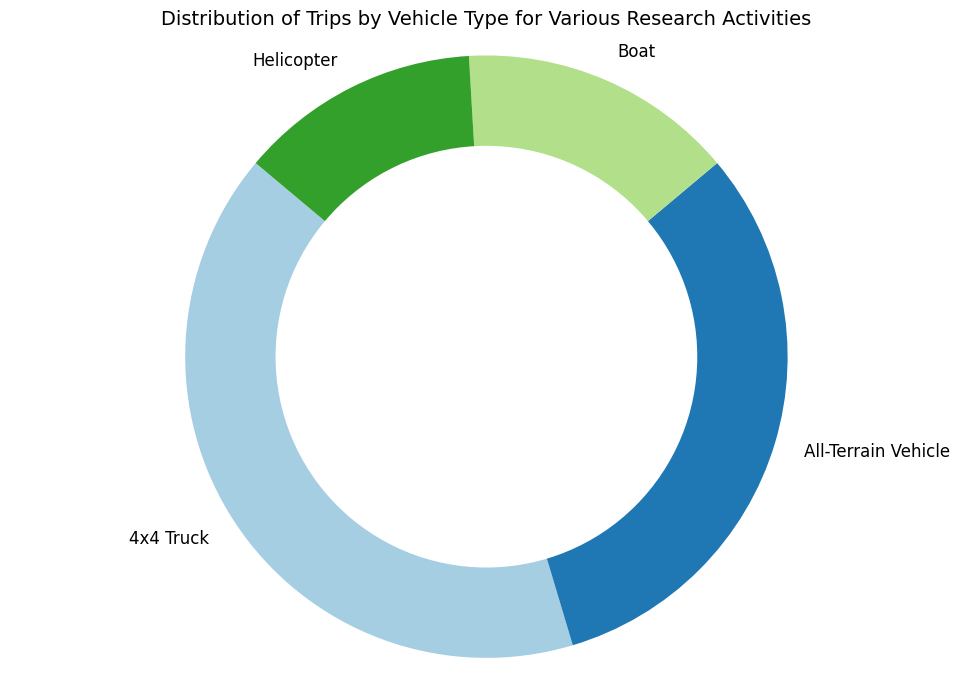What is the total percentage of trips made by All-Terrain Vehicles and 4x4 Trucks combined? Combine the percentages of trips made by All-Terrain Vehicles and 4x4 Trucks. From the chart, All-Terrain Vehicles account for 29.6% and 4x4 Trucks account for 39.4%. Adding these together: 29.6 + 39.4 = 69.0%
Answer: 69.0% Which vehicle type made the fewest trips overall? Identify the smallest percentage segment in the pie chart. The Helicopter segment appears to be the smallest.
Answer: Helicopter Is the percentage of trips made by Boats greater than or less than the percentage of trips made by All-Terrain Vehicles? Compare the size of the segments representing Boats and All-Terrain Vehicles. Boats account for a smaller portion than All-Terrain Vehicles.
Answer: Less than Which vehicle type made the greatest number of trips for habitat monitoring? Identify the vehicle type with the largest segment for the habitat monitoring category in the chart. 4x4 Truck's segment for habitat monitoring is the largest.
Answer: 4x4 Truck How many more trips did All-Terrain Vehicles make for wildlife tracking compared to Helicopters? Calculate the difference between the number of trips made by All-Terrain Vehicles and Helicopters specifically for wildlife tracking. All-Terrain Vehicles made 40 trips, and Helicopters made 10 trips. The difference is 40 - 10 = 30.
Answer: 30 What is the total number of trips made by Helicopters for all research activities? Sum the number of trips made by Helicopters across all categories. For Helicopters, the trips are 10 (Wildlife Tracking) + 15 (Habitat Monitoring) + 5 (Personnel Transport) + 5 (Equipment Transport) = 35.
Answer: 35 How does the percentage of trips made by 4x4 Trucks compare to the total percentage of trips made by Helicopters and Boats combined? First, find the combined percentage of trips made by Helicopters and Boats. Helicopters account for 12.3%, and Boats account for 19.8%. Therefore, combined, they account for 12.3 + 19.8 = 32.1%. Compare this with the 4x4 Trucks' percentage, which is 39.4%. 39.4% (4x4 Trucks) is greater than 32.1% (Helicopters and Boats combined).
Answer: Greater than If All-Terrain Vehicles made 80 trips in total, what is the average number of trips per activity category for All-Terrain Vehicles? Given that All-Terrain Vehicles made 80 trips in total, and there are 4 categories, the average per category is calculated as 80 / 4 = 20.
Answer: 20 What percent of trips does the Equipment Transport category represent for Boats? Find the number of trips made by Boats for Equipment Transport and divide it by the total number of trips by Boats. Boats made 5 trips for Equipment Transport out of 40 total trips. The percentage is (5 / 40) × 100 = 12.5%.
Answer: 12.5% 